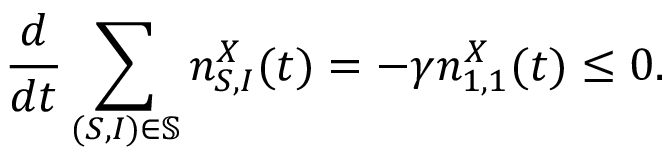<formula> <loc_0><loc_0><loc_500><loc_500>\frac { d } { d t } \sum _ { ( S , I ) \in \mathbb { S } } n _ { S , I } ^ { X } ( t ) = - \gamma n _ { 1 , 1 } ^ { X } ( t ) \leq 0 .</formula> 